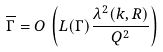Convert formula to latex. <formula><loc_0><loc_0><loc_500><loc_500>\overline { \Gamma } = O \, \left ( L ( \Gamma ) \frac { \lambda ^ { 2 } ( k , R ) } { Q ^ { 2 } } \right )</formula> 